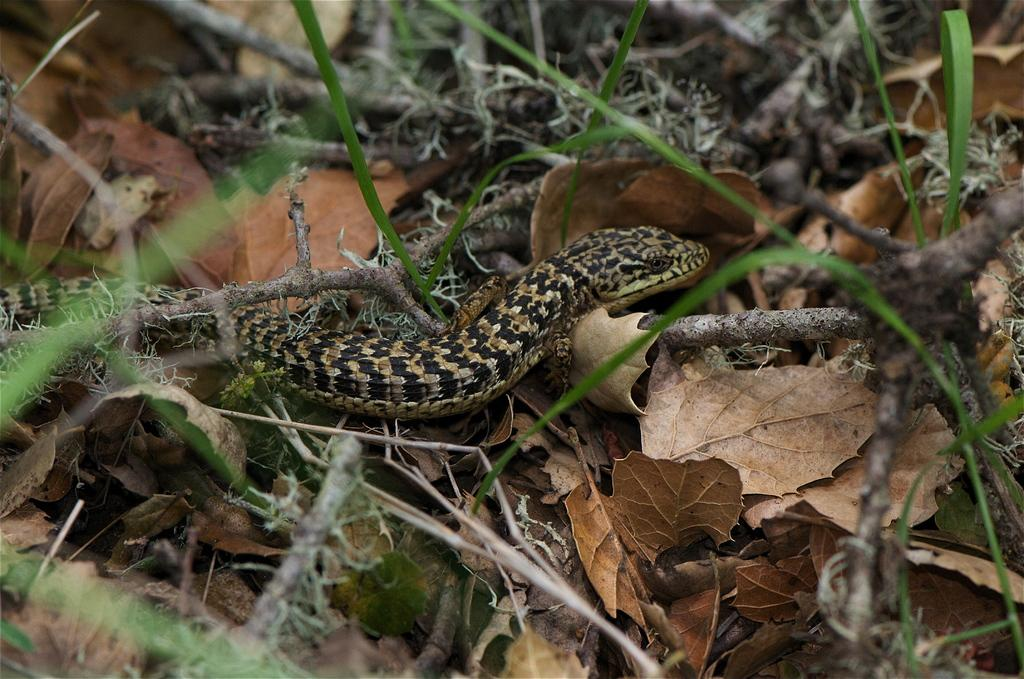What type of animal is in the image? There is a black and brown snake in the image. What is the snake resting on? The snake is on dry leaves and plant branches. What advice does the snake's father give it in the image? There is no father figure present in the image, nor is there any indication of advice being given. 